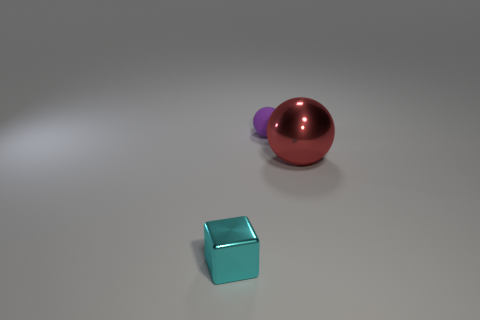How do the shadows cast by the objects interact with each other? The shadows in the image are subtle yet telling. The cyan cube casts a well-defined shadow that indicates a singular, strong light source. There is a faint shadow interaction near the base of the red sphere, suggesting the objects are close enough for their shadows to mingle. The play of light and shadow adds a dimensional quality to the scene and hints at the physical relationship between these objects. 